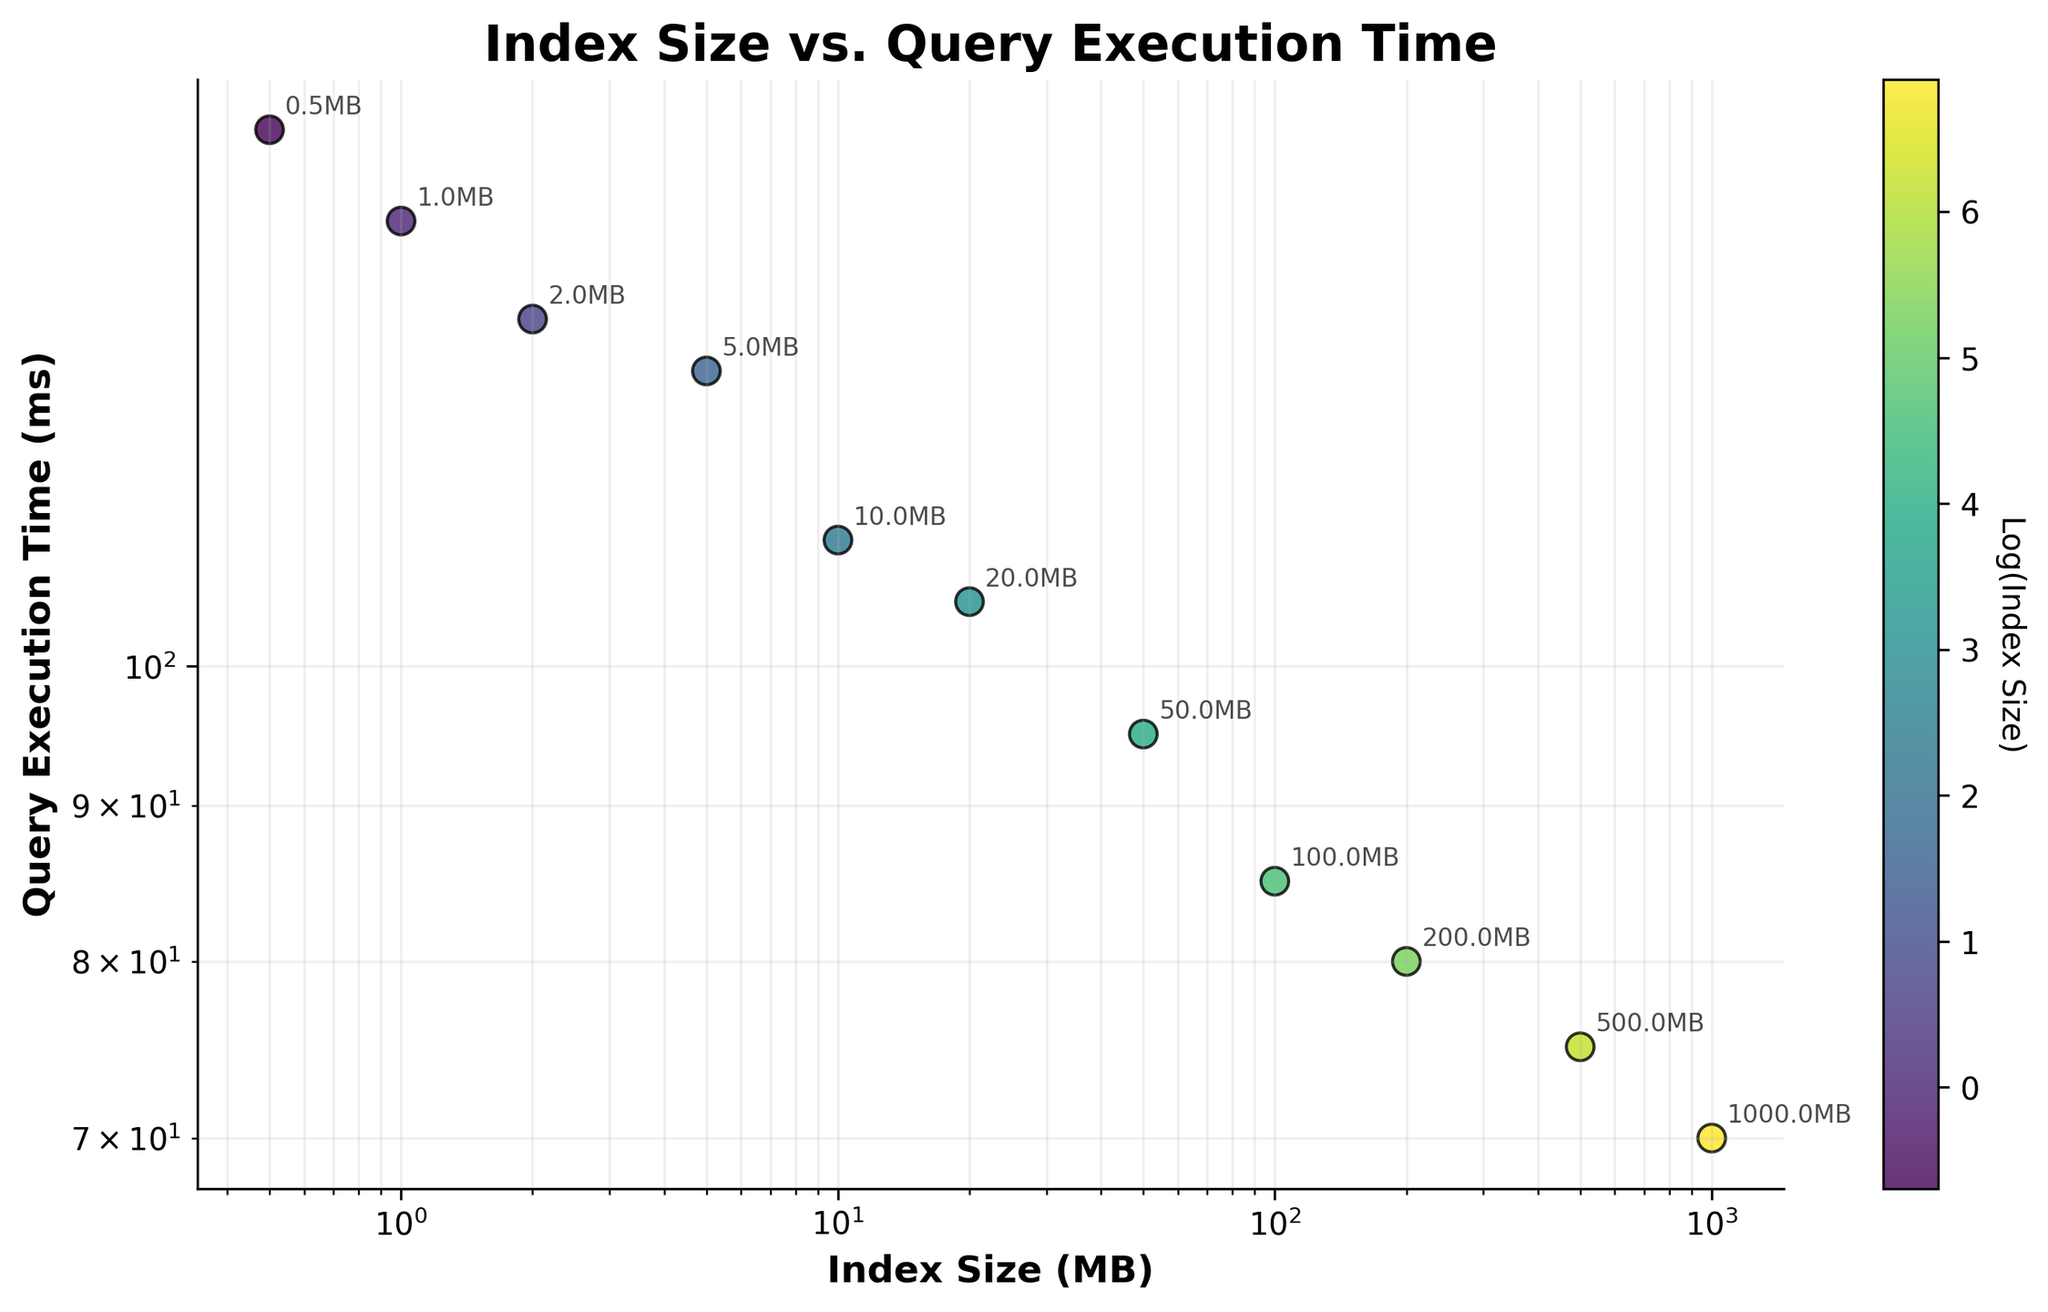What's the title of the figure? The title of the figure is positioned at the top center of the plot and directly describes the content. It reads "Index Size vs. Query Execution Time".
Answer: Index Size vs. Query Execution Time How many data points are in the scatter plot? Count the number of dots in the plot. Each dot represents a data point. There are 11 data points.
Answer: 11 What colors are used to represent the data points? Each data point is colored using a color scale from the 'viridis' colormap based on the logarithm of the index size values. These colors range from blue to yellow.
Answer: Blue to yellow What's the x-axis label? The label for the x-axis can be found at the bottom of the plot. It reads "Index Size (MB)".
Answer: Index Size (MB) What's the y-axis label? The label for the y-axis is located on the left side of the plot and reads "Query Execution Time (ms)".
Answer: Query Execution Time (ms) Which data point has the smallest index size, and what is the corresponding query execution time? Identify the smallest index size value and its associated query execution time. The smallest index size is 0.5 MB, and its corresponding query execution time is 150 ms.
Answer: 0.5 MB, 150 ms Comparing the data points with index sizes of 10 MB and 100 MB, which one has a shorter query execution time? Look at the y-axis values for the data points with index sizes of 10 MB and 100 MB. The query execution time for 10 MB is 110 ms, while for 100 MB it is 85 ms. Therefore, 100 MB has a shorter query execution time.
Answer: 100 MB On a log-log scale, how does the query execution time change as the index size increases from 100 MB to 1000 MB? Examine the trend between these data points on the log-log scales. The query execution time decreases as the index size increases from 100 MB (with 85 ms) to 1000 MB (with 70 ms).
Answer: Decreases Which data point is the most logarithmically distant from the others in terms of index size? Identify the point with the largest index size, which will have the highest value on the x-axis log scale. This is the data point with an index size of 1000 MB.
Answer: 1000 MB What is the trend observed between index size and query execution time on the plot? The data points show a downward trend, indicating that as the index size increases, the query execution time generally decreases. This trend is more noticeable in a log-log scale.
Answer: Decreases 